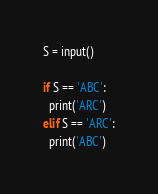<code> <loc_0><loc_0><loc_500><loc_500><_Python_>S = input()

if S == 'ABC':
  print('ARC')
elif S == 'ARC':
  print('ABC')</code> 